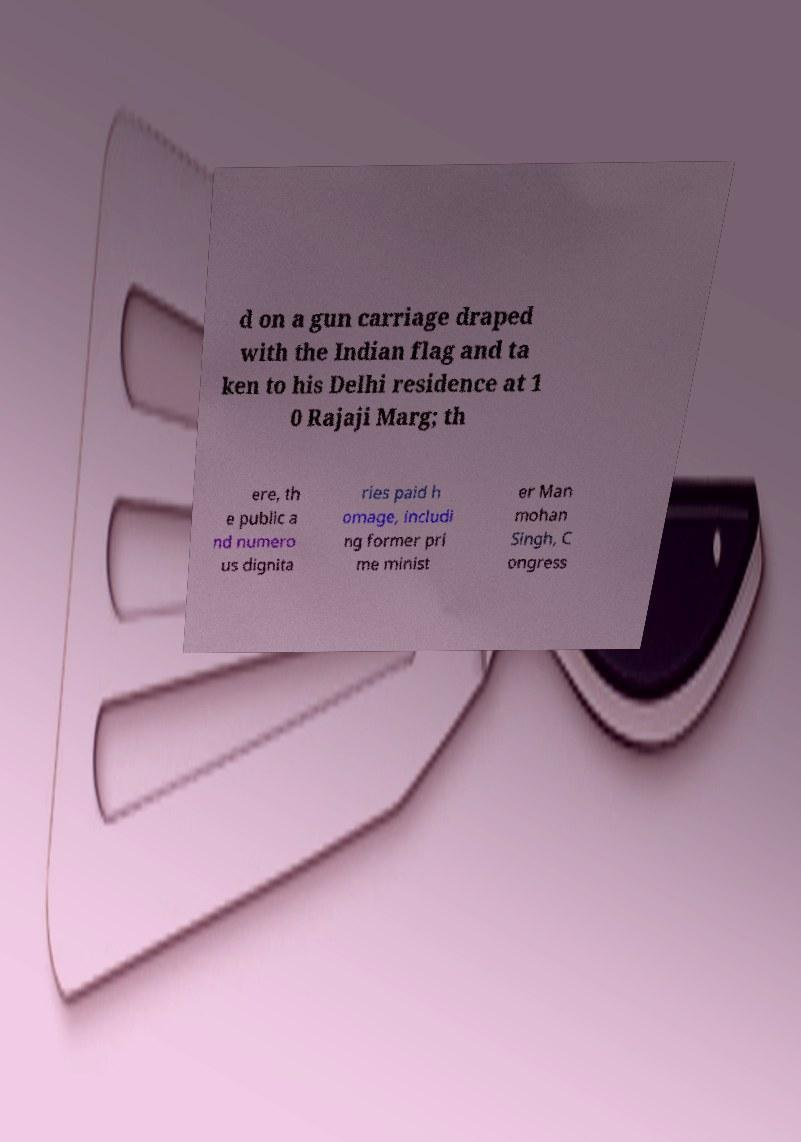Can you accurately transcribe the text from the provided image for me? d on a gun carriage draped with the Indian flag and ta ken to his Delhi residence at 1 0 Rajaji Marg; th ere, th e public a nd numero us dignita ries paid h omage, includi ng former pri me minist er Man mohan Singh, C ongress 